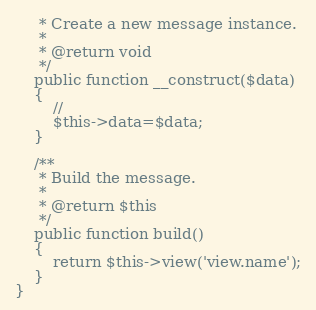Convert code to text. <code><loc_0><loc_0><loc_500><loc_500><_PHP_>     * Create a new message instance.
     *
     * @return void
     */
    public function __construct($data)
    {
        //
		$this->data=$data;
    }

    /**
     * Build the message.
     *
     * @return $this
     */
    public function build()
    {
        return $this->view('view.name');
    }
}
</code> 